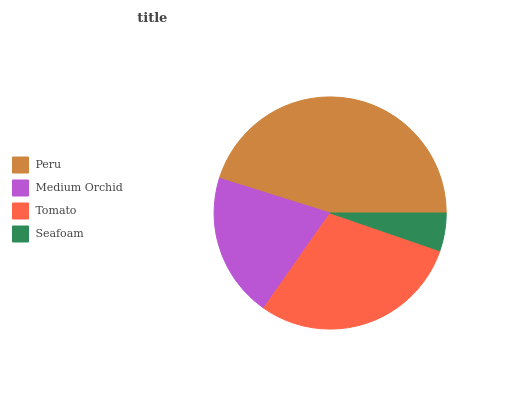Is Seafoam the minimum?
Answer yes or no. Yes. Is Peru the maximum?
Answer yes or no. Yes. Is Medium Orchid the minimum?
Answer yes or no. No. Is Medium Orchid the maximum?
Answer yes or no. No. Is Peru greater than Medium Orchid?
Answer yes or no. Yes. Is Medium Orchid less than Peru?
Answer yes or no. Yes. Is Medium Orchid greater than Peru?
Answer yes or no. No. Is Peru less than Medium Orchid?
Answer yes or no. No. Is Tomato the high median?
Answer yes or no. Yes. Is Medium Orchid the low median?
Answer yes or no. Yes. Is Peru the high median?
Answer yes or no. No. Is Peru the low median?
Answer yes or no. No. 